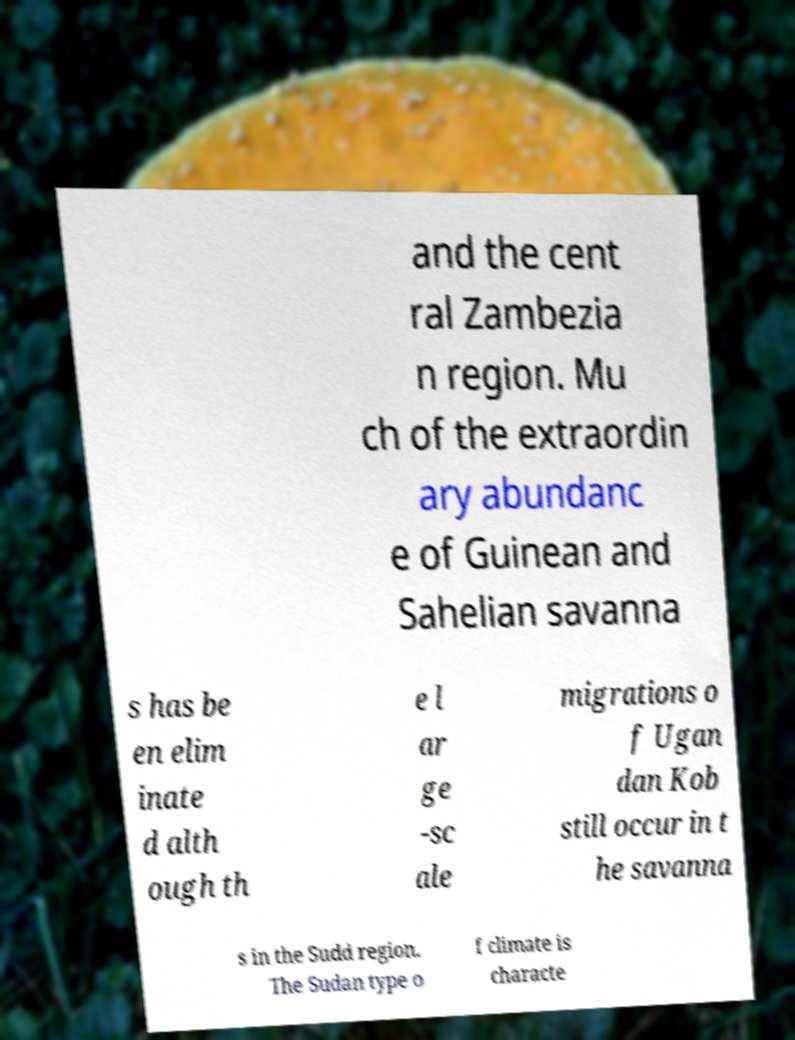Could you extract and type out the text from this image? and the cent ral Zambezia n region. Mu ch of the extraordin ary abundanc e of Guinean and Sahelian savanna s has be en elim inate d alth ough th e l ar ge -sc ale migrations o f Ugan dan Kob still occur in t he savanna s in the Sudd region. The Sudan type o f climate is characte 